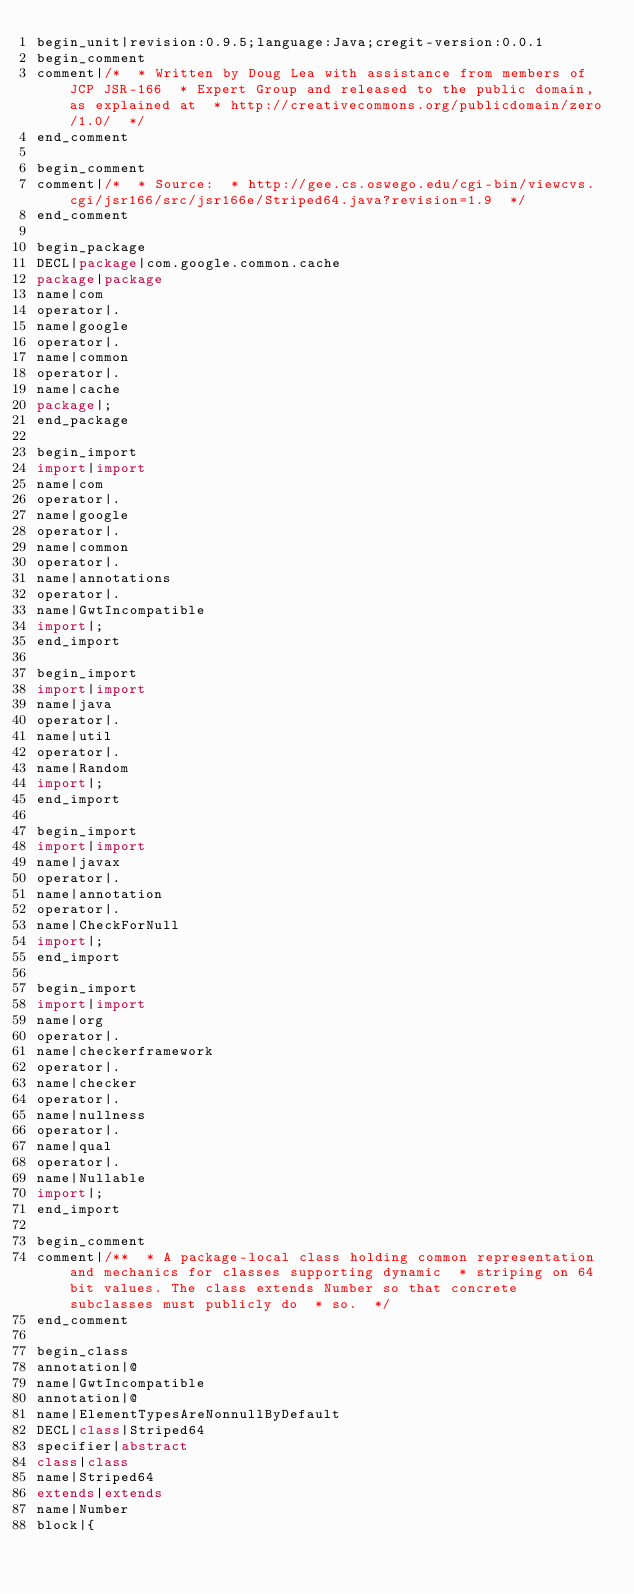<code> <loc_0><loc_0><loc_500><loc_500><_Java_>begin_unit|revision:0.9.5;language:Java;cregit-version:0.0.1
begin_comment
comment|/*  * Written by Doug Lea with assistance from members of JCP JSR-166  * Expert Group and released to the public domain, as explained at  * http://creativecommons.org/publicdomain/zero/1.0/  */
end_comment

begin_comment
comment|/*  * Source:  * http://gee.cs.oswego.edu/cgi-bin/viewcvs.cgi/jsr166/src/jsr166e/Striped64.java?revision=1.9  */
end_comment

begin_package
DECL|package|com.google.common.cache
package|package
name|com
operator|.
name|google
operator|.
name|common
operator|.
name|cache
package|;
end_package

begin_import
import|import
name|com
operator|.
name|google
operator|.
name|common
operator|.
name|annotations
operator|.
name|GwtIncompatible
import|;
end_import

begin_import
import|import
name|java
operator|.
name|util
operator|.
name|Random
import|;
end_import

begin_import
import|import
name|javax
operator|.
name|annotation
operator|.
name|CheckForNull
import|;
end_import

begin_import
import|import
name|org
operator|.
name|checkerframework
operator|.
name|checker
operator|.
name|nullness
operator|.
name|qual
operator|.
name|Nullable
import|;
end_import

begin_comment
comment|/**  * A package-local class holding common representation and mechanics for classes supporting dynamic  * striping on 64bit values. The class extends Number so that concrete subclasses must publicly do  * so.  */
end_comment

begin_class
annotation|@
name|GwtIncompatible
annotation|@
name|ElementTypesAreNonnullByDefault
DECL|class|Striped64
specifier|abstract
class|class
name|Striped64
extends|extends
name|Number
block|{</code> 